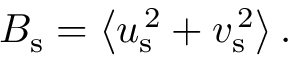<formula> <loc_0><loc_0><loc_500><loc_500>{ B } _ { s } = \left < { u } _ { s } ^ { \, 2 } + { v } _ { s } ^ { \, 2 } \right > .</formula> 